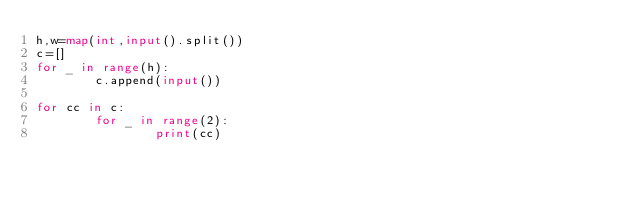Convert code to text. <code><loc_0><loc_0><loc_500><loc_500><_Python_>h,w=map(int,input().split())
c=[]
for _ in range(h):
        c.append(input())

for cc in c:
        for _ in range(2):
                print(cc)            </code> 